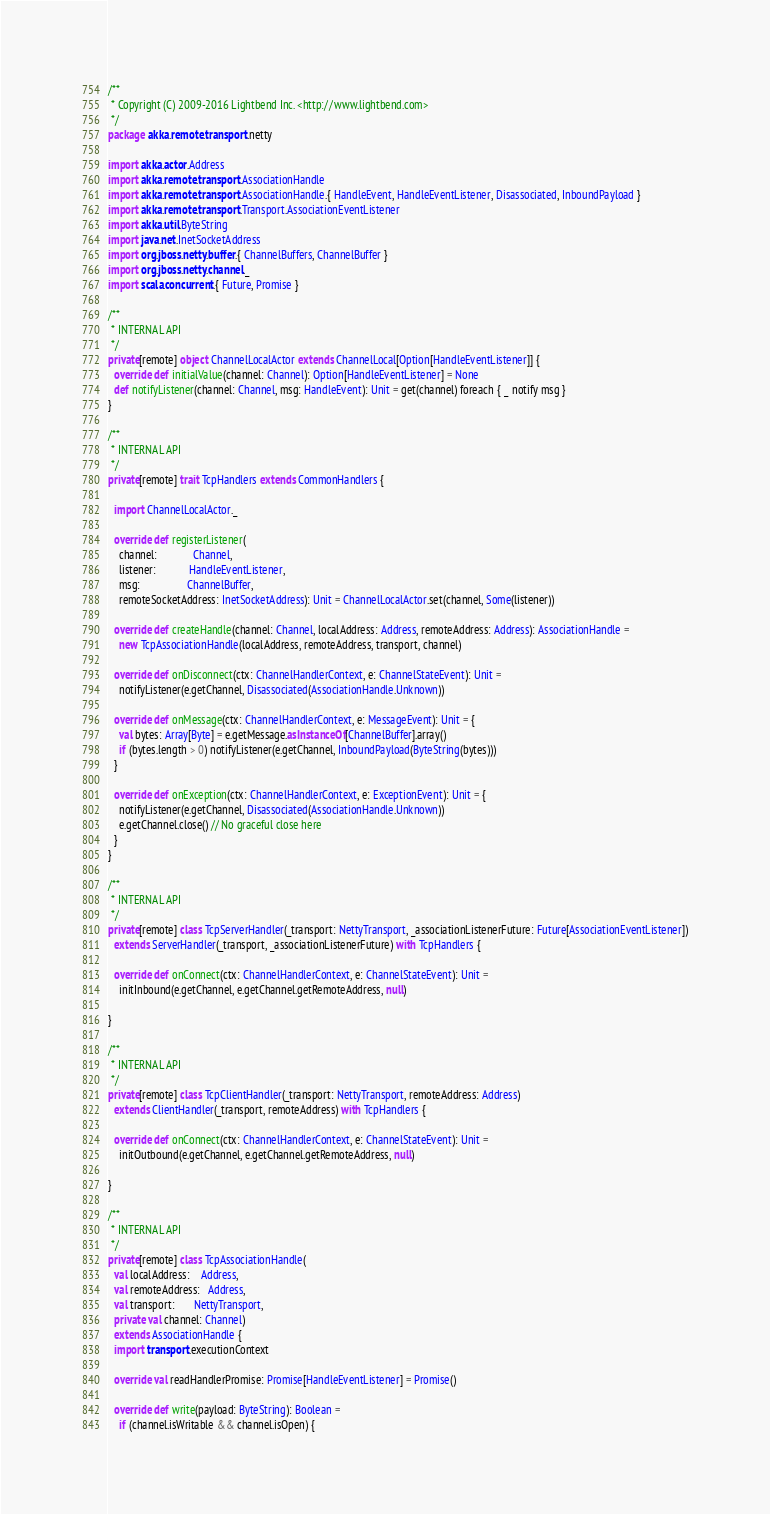Convert code to text. <code><loc_0><loc_0><loc_500><loc_500><_Scala_>/**
 * Copyright (C) 2009-2016 Lightbend Inc. <http://www.lightbend.com>
 */
package akka.remote.transport.netty

import akka.actor.Address
import akka.remote.transport.AssociationHandle
import akka.remote.transport.AssociationHandle.{ HandleEvent, HandleEventListener, Disassociated, InboundPayload }
import akka.remote.transport.Transport.AssociationEventListener
import akka.util.ByteString
import java.net.InetSocketAddress
import org.jboss.netty.buffer.{ ChannelBuffers, ChannelBuffer }
import org.jboss.netty.channel._
import scala.concurrent.{ Future, Promise }

/**
 * INTERNAL API
 */
private[remote] object ChannelLocalActor extends ChannelLocal[Option[HandleEventListener]] {
  override def initialValue(channel: Channel): Option[HandleEventListener] = None
  def notifyListener(channel: Channel, msg: HandleEvent): Unit = get(channel) foreach { _ notify msg }
}

/**
 * INTERNAL API
 */
private[remote] trait TcpHandlers extends CommonHandlers {

  import ChannelLocalActor._

  override def registerListener(
    channel:             Channel,
    listener:            HandleEventListener,
    msg:                 ChannelBuffer,
    remoteSocketAddress: InetSocketAddress): Unit = ChannelLocalActor.set(channel, Some(listener))

  override def createHandle(channel: Channel, localAddress: Address, remoteAddress: Address): AssociationHandle =
    new TcpAssociationHandle(localAddress, remoteAddress, transport, channel)

  override def onDisconnect(ctx: ChannelHandlerContext, e: ChannelStateEvent): Unit =
    notifyListener(e.getChannel, Disassociated(AssociationHandle.Unknown))

  override def onMessage(ctx: ChannelHandlerContext, e: MessageEvent): Unit = {
    val bytes: Array[Byte] = e.getMessage.asInstanceOf[ChannelBuffer].array()
    if (bytes.length > 0) notifyListener(e.getChannel, InboundPayload(ByteString(bytes)))
  }

  override def onException(ctx: ChannelHandlerContext, e: ExceptionEvent): Unit = {
    notifyListener(e.getChannel, Disassociated(AssociationHandle.Unknown))
    e.getChannel.close() // No graceful close here
  }
}

/**
 * INTERNAL API
 */
private[remote] class TcpServerHandler(_transport: NettyTransport, _associationListenerFuture: Future[AssociationEventListener])
  extends ServerHandler(_transport, _associationListenerFuture) with TcpHandlers {

  override def onConnect(ctx: ChannelHandlerContext, e: ChannelStateEvent): Unit =
    initInbound(e.getChannel, e.getChannel.getRemoteAddress, null)

}

/**
 * INTERNAL API
 */
private[remote] class TcpClientHandler(_transport: NettyTransport, remoteAddress: Address)
  extends ClientHandler(_transport, remoteAddress) with TcpHandlers {

  override def onConnect(ctx: ChannelHandlerContext, e: ChannelStateEvent): Unit =
    initOutbound(e.getChannel, e.getChannel.getRemoteAddress, null)

}

/**
 * INTERNAL API
 */
private[remote] class TcpAssociationHandle(
  val localAddress:    Address,
  val remoteAddress:   Address,
  val transport:       NettyTransport,
  private val channel: Channel)
  extends AssociationHandle {
  import transport.executionContext

  override val readHandlerPromise: Promise[HandleEventListener] = Promise()

  override def write(payload: ByteString): Boolean =
    if (channel.isWritable && channel.isOpen) {</code> 